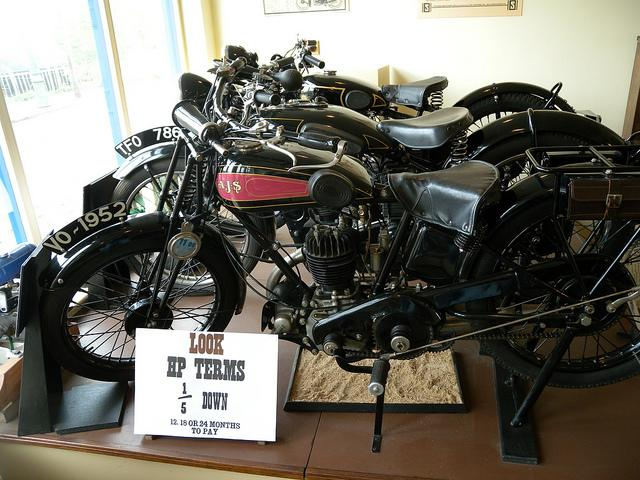What are the terms referring to? Please explain your reasoning. financing. The sign says "12, 15 or 25 months pay" which is financing. 